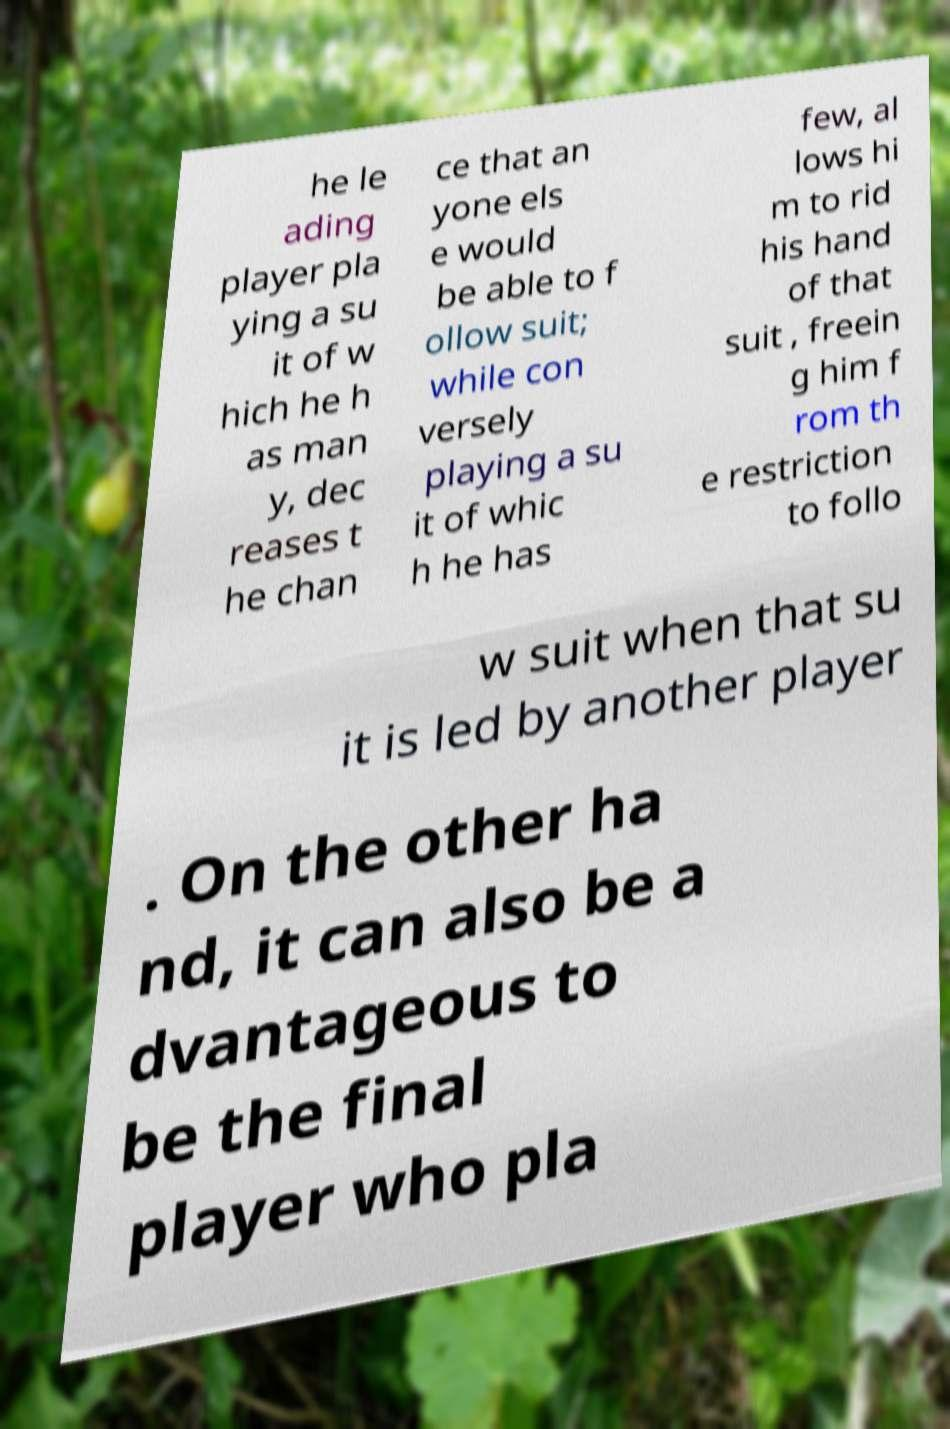Can you accurately transcribe the text from the provided image for me? he le ading player pla ying a su it of w hich he h as man y, dec reases t he chan ce that an yone els e would be able to f ollow suit; while con versely playing a su it of whic h he has few, al lows hi m to rid his hand of that suit , freein g him f rom th e restriction to follo w suit when that su it is led by another player . On the other ha nd, it can also be a dvantageous to be the final player who pla 